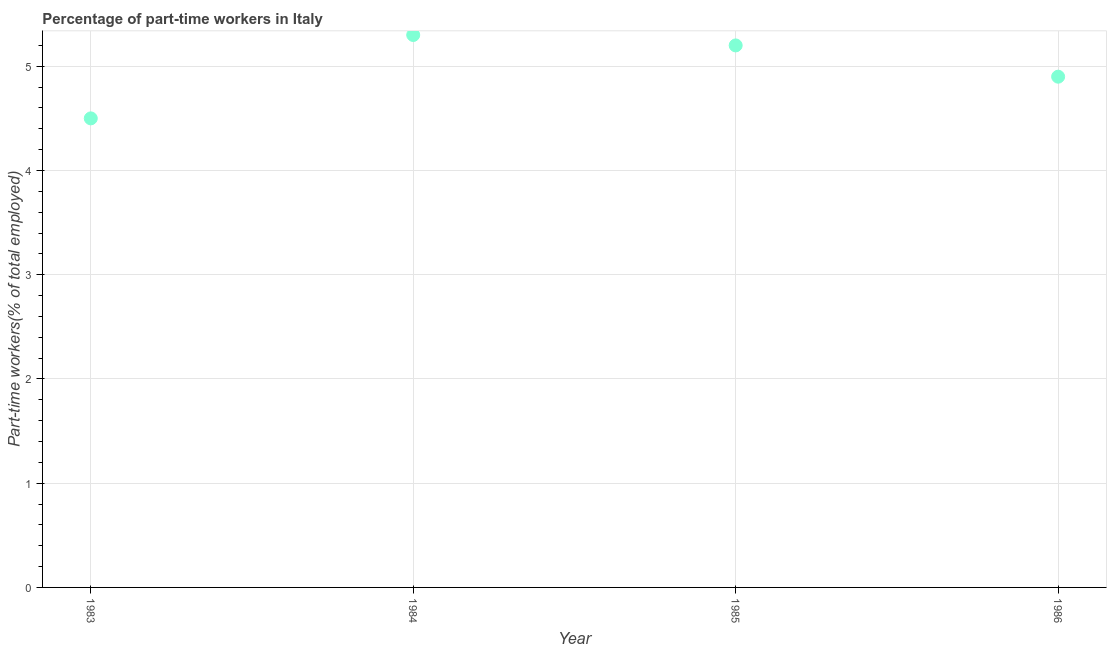What is the percentage of part-time workers in 1986?
Give a very brief answer. 4.9. Across all years, what is the maximum percentage of part-time workers?
Offer a terse response. 5.3. In which year was the percentage of part-time workers maximum?
Offer a terse response. 1984. What is the sum of the percentage of part-time workers?
Your answer should be very brief. 19.9. What is the difference between the percentage of part-time workers in 1985 and 1986?
Provide a short and direct response. 0.3. What is the average percentage of part-time workers per year?
Provide a succinct answer. 4.98. What is the median percentage of part-time workers?
Provide a short and direct response. 5.05. Do a majority of the years between 1986 and 1984 (inclusive) have percentage of part-time workers greater than 2.6 %?
Offer a very short reply. No. What is the ratio of the percentage of part-time workers in 1983 to that in 1984?
Your response must be concise. 0.85. Is the difference between the percentage of part-time workers in 1983 and 1984 greater than the difference between any two years?
Your response must be concise. Yes. What is the difference between the highest and the second highest percentage of part-time workers?
Your answer should be compact. 0.1. Is the sum of the percentage of part-time workers in 1985 and 1986 greater than the maximum percentage of part-time workers across all years?
Give a very brief answer. Yes. What is the difference between the highest and the lowest percentage of part-time workers?
Offer a very short reply. 0.8. How many dotlines are there?
Offer a terse response. 1. What is the difference between two consecutive major ticks on the Y-axis?
Provide a succinct answer. 1. Are the values on the major ticks of Y-axis written in scientific E-notation?
Offer a terse response. No. What is the title of the graph?
Keep it short and to the point. Percentage of part-time workers in Italy. What is the label or title of the X-axis?
Your answer should be very brief. Year. What is the label or title of the Y-axis?
Offer a very short reply. Part-time workers(% of total employed). What is the Part-time workers(% of total employed) in 1984?
Offer a terse response. 5.3. What is the Part-time workers(% of total employed) in 1985?
Provide a short and direct response. 5.2. What is the Part-time workers(% of total employed) in 1986?
Give a very brief answer. 4.9. What is the difference between the Part-time workers(% of total employed) in 1983 and 1984?
Keep it short and to the point. -0.8. What is the difference between the Part-time workers(% of total employed) in 1983 and 1985?
Make the answer very short. -0.7. What is the difference between the Part-time workers(% of total employed) in 1983 and 1986?
Provide a succinct answer. -0.4. What is the difference between the Part-time workers(% of total employed) in 1984 and 1985?
Give a very brief answer. 0.1. What is the difference between the Part-time workers(% of total employed) in 1984 and 1986?
Ensure brevity in your answer.  0.4. What is the ratio of the Part-time workers(% of total employed) in 1983 to that in 1984?
Your answer should be compact. 0.85. What is the ratio of the Part-time workers(% of total employed) in 1983 to that in 1985?
Keep it short and to the point. 0.86. What is the ratio of the Part-time workers(% of total employed) in 1983 to that in 1986?
Make the answer very short. 0.92. What is the ratio of the Part-time workers(% of total employed) in 1984 to that in 1986?
Ensure brevity in your answer.  1.08. What is the ratio of the Part-time workers(% of total employed) in 1985 to that in 1986?
Give a very brief answer. 1.06. 